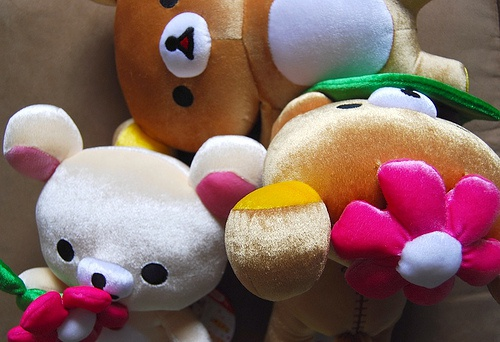Describe the objects in this image and their specific colors. I can see a teddy bear in gray, lightgray, maroon, and black tones in this image. 